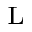<formula> <loc_0><loc_0><loc_500><loc_500>_ { L }</formula> 